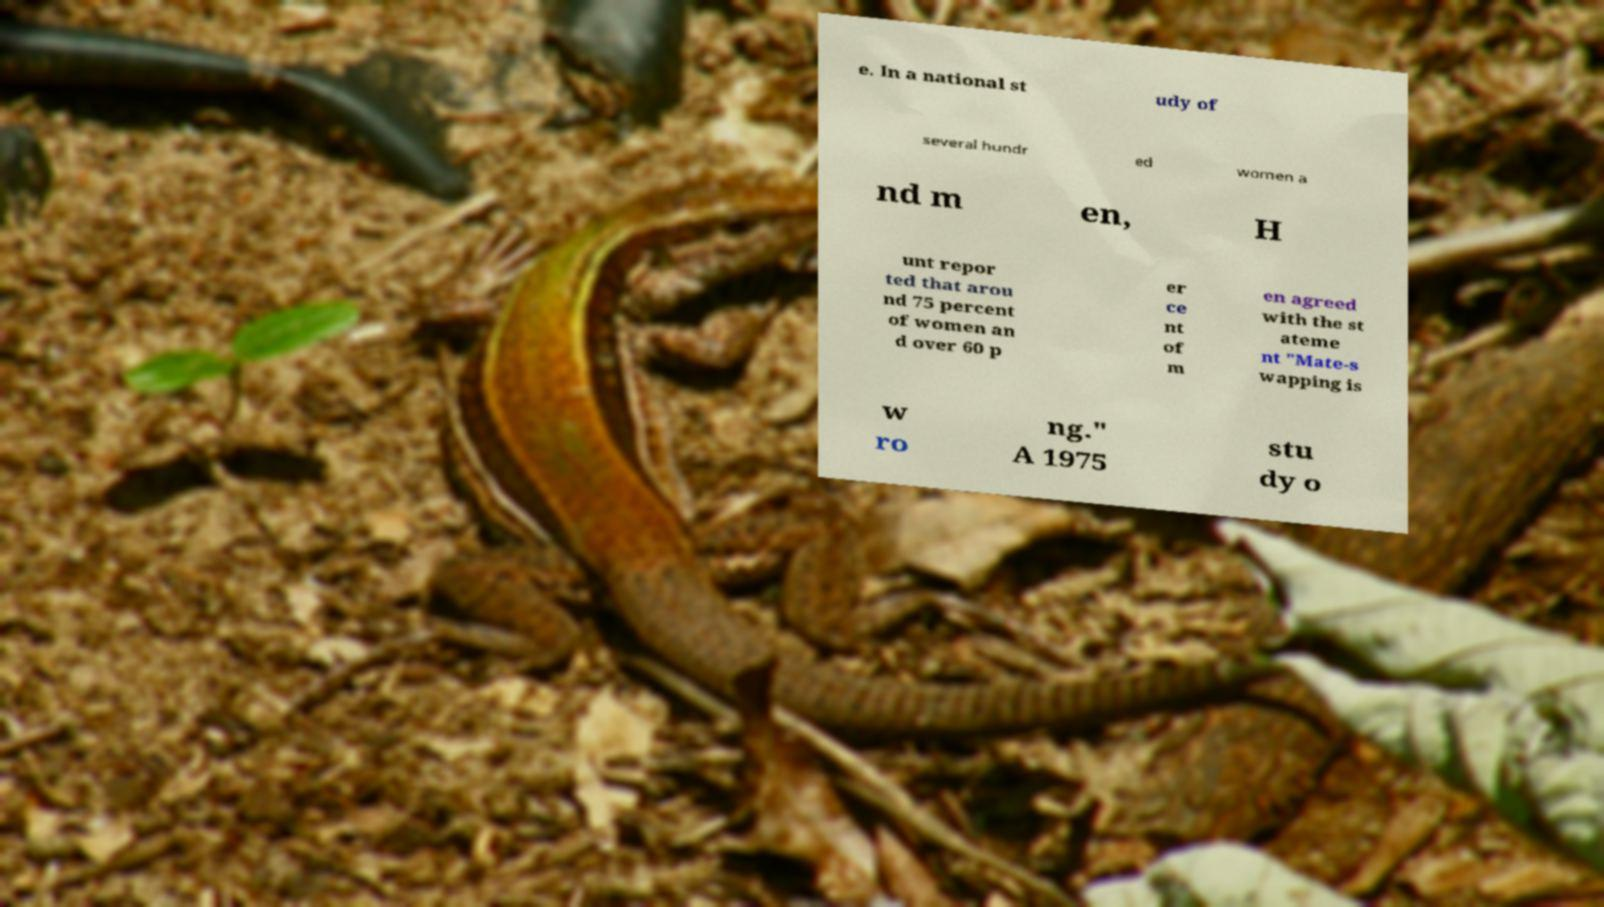For documentation purposes, I need the text within this image transcribed. Could you provide that? e. In a national st udy of several hundr ed women a nd m en, H unt repor ted that arou nd 75 percent of women an d over 60 p er ce nt of m en agreed with the st ateme nt "Mate-s wapping is w ro ng." A 1975 stu dy o 